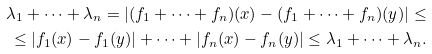Convert formula to latex. <formula><loc_0><loc_0><loc_500><loc_500>\lambda _ { 1 } + \dots + \lambda _ { n } = | ( f _ { 1 } + \dots + f _ { n } ) ( x ) - ( f _ { 1 } + \dots + f _ { n } ) ( y ) | \leq \\ \leq | f _ { 1 } ( x ) - f _ { 1 } ( y ) | + \dots + | f _ { n } ( x ) - f _ { n } ( y ) | \leq \lambda _ { 1 } + \dots + \lambda _ { n } .</formula> 